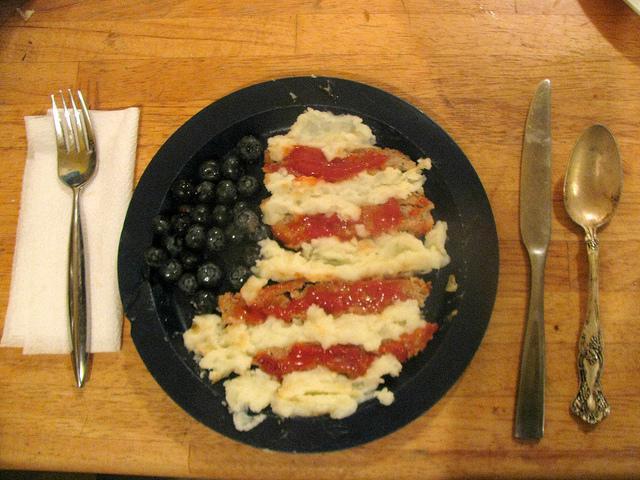How many skis is the man using?
Give a very brief answer. 0. 